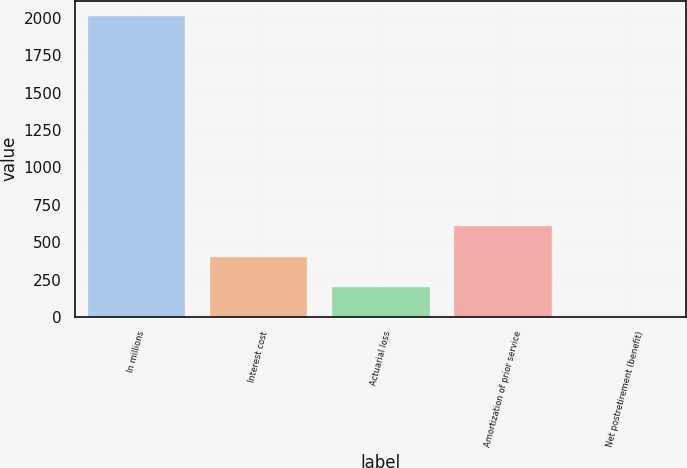Convert chart to OTSL. <chart><loc_0><loc_0><loc_500><loc_500><bar_chart><fcel>In millions<fcel>Interest cost<fcel>Actuarial loss<fcel>Amortization of prior service<fcel>Net postretirement (benefit)<nl><fcel>2016<fcel>404<fcel>202.5<fcel>605.5<fcel>1<nl></chart> 